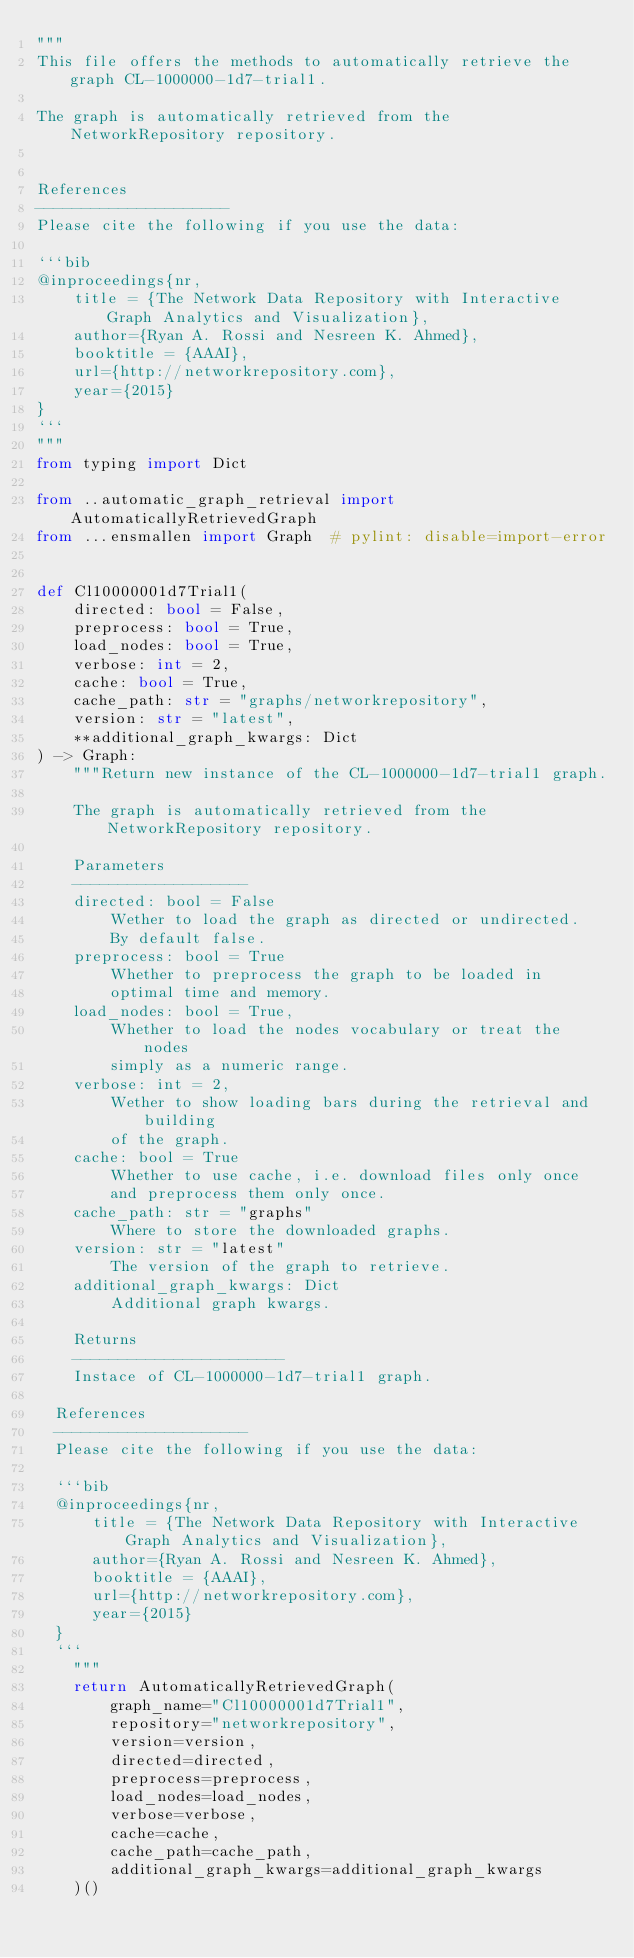<code> <loc_0><loc_0><loc_500><loc_500><_Python_>"""
This file offers the methods to automatically retrieve the graph CL-1000000-1d7-trial1.

The graph is automatically retrieved from the NetworkRepository repository. 


References
---------------------
Please cite the following if you use the data:

```bib
@inproceedings{nr,
    title = {The Network Data Repository with Interactive Graph Analytics and Visualization},
    author={Ryan A. Rossi and Nesreen K. Ahmed},
    booktitle = {AAAI},
    url={http://networkrepository.com},
    year={2015}
}
```
"""
from typing import Dict

from ..automatic_graph_retrieval import AutomaticallyRetrievedGraph
from ...ensmallen import Graph  # pylint: disable=import-error


def Cl10000001d7Trial1(
    directed: bool = False,
    preprocess: bool = True,
    load_nodes: bool = True,
    verbose: int = 2,
    cache: bool = True,
    cache_path: str = "graphs/networkrepository",
    version: str = "latest",
    **additional_graph_kwargs: Dict
) -> Graph:
    """Return new instance of the CL-1000000-1d7-trial1 graph.

    The graph is automatically retrieved from the NetworkRepository repository.	

    Parameters
    -------------------
    directed: bool = False
        Wether to load the graph as directed or undirected.
        By default false.
    preprocess: bool = True
        Whether to preprocess the graph to be loaded in 
        optimal time and memory.
    load_nodes: bool = True,
        Whether to load the nodes vocabulary or treat the nodes
        simply as a numeric range.
    verbose: int = 2,
        Wether to show loading bars during the retrieval and building
        of the graph.
    cache: bool = True
        Whether to use cache, i.e. download files only once
        and preprocess them only once.
    cache_path: str = "graphs"
        Where to store the downloaded graphs.
    version: str = "latest"
        The version of the graph to retrieve.	
    additional_graph_kwargs: Dict
        Additional graph kwargs.

    Returns
    -----------------------
    Instace of CL-1000000-1d7-trial1 graph.

	References
	---------------------
	Please cite the following if you use the data:
	
	```bib
	@inproceedings{nr,
	    title = {The Network Data Repository with Interactive Graph Analytics and Visualization},
	    author={Ryan A. Rossi and Nesreen K. Ahmed},
	    booktitle = {AAAI},
	    url={http://networkrepository.com},
	    year={2015}
	}
	```
    """
    return AutomaticallyRetrievedGraph(
        graph_name="Cl10000001d7Trial1",
        repository="networkrepository",
        version=version,
        directed=directed,
        preprocess=preprocess,
        load_nodes=load_nodes,
        verbose=verbose,
        cache=cache,
        cache_path=cache_path,
        additional_graph_kwargs=additional_graph_kwargs
    )()
</code> 